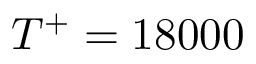<formula> <loc_0><loc_0><loc_500><loc_500>T ^ { + } = 1 8 0 0 0</formula> 